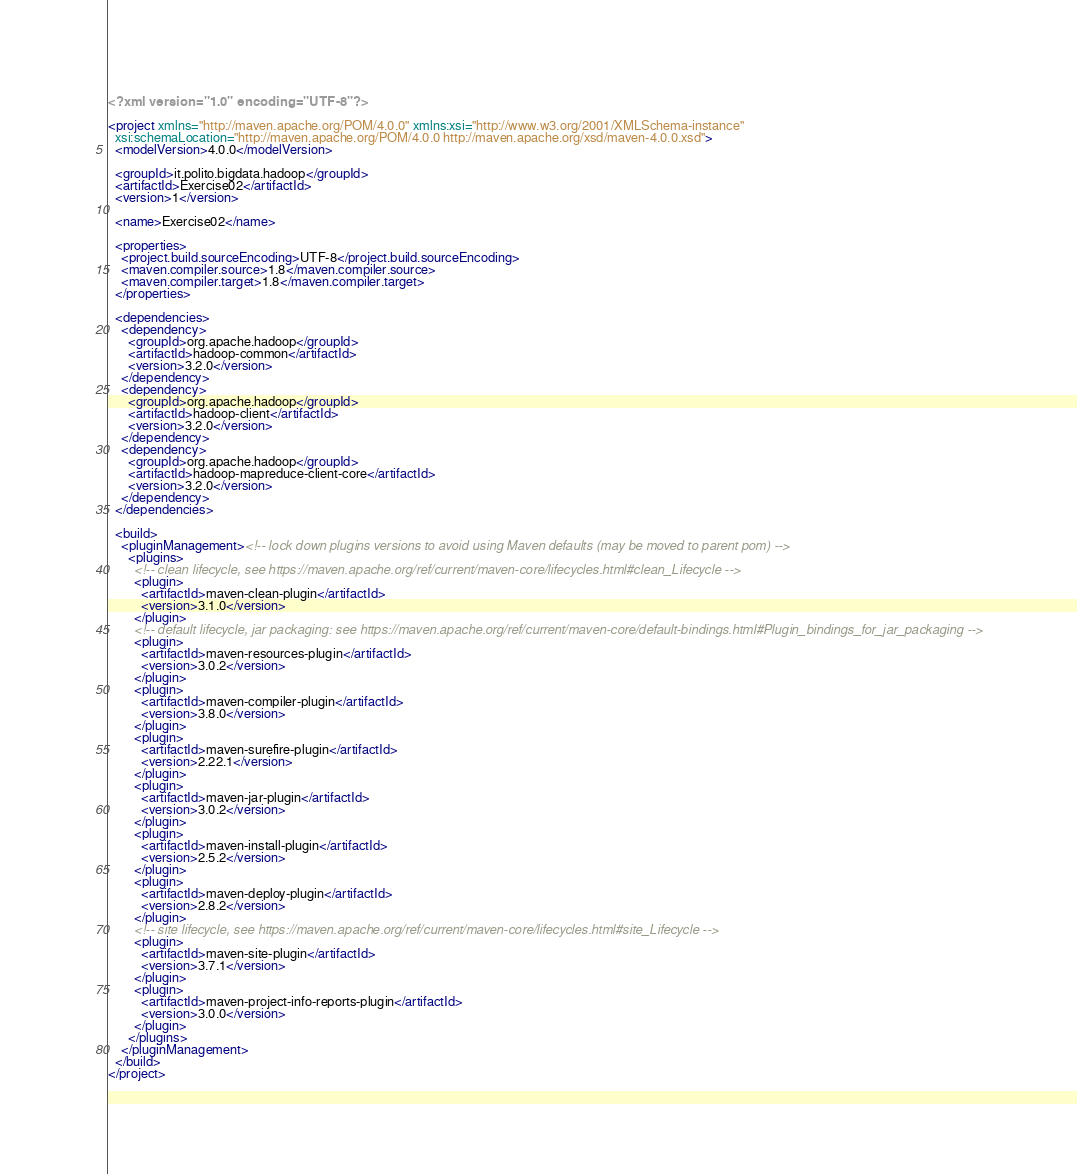<code> <loc_0><loc_0><loc_500><loc_500><_XML_><?xml version="1.0" encoding="UTF-8"?>

<project xmlns="http://maven.apache.org/POM/4.0.0" xmlns:xsi="http://www.w3.org/2001/XMLSchema-instance"
  xsi:schemaLocation="http://maven.apache.org/POM/4.0.0 http://maven.apache.org/xsd/maven-4.0.0.xsd">
  <modelVersion>4.0.0</modelVersion>

  <groupId>it.polito.bigdata.hadoop</groupId>
  <artifactId>Exercise02</artifactId>
  <version>1</version>

  <name>Exercise02</name>

  <properties>
    <project.build.sourceEncoding>UTF-8</project.build.sourceEncoding>
    <maven.compiler.source>1.8</maven.compiler.source>
    <maven.compiler.target>1.8</maven.compiler.target>
  </properties>

  <dependencies>
    <dependency>
      <groupId>org.apache.hadoop</groupId>
      <artifactId>hadoop-common</artifactId>
      <version>3.2.0</version>
    </dependency>
    <dependency>
      <groupId>org.apache.hadoop</groupId>
      <artifactId>hadoop-client</artifactId>
      <version>3.2.0</version>
    </dependency>
    <dependency>
      <groupId>org.apache.hadoop</groupId>
      <artifactId>hadoop-mapreduce-client-core</artifactId>
      <version>3.2.0</version>
    </dependency>
  </dependencies>

  <build>
    <pluginManagement><!-- lock down plugins versions to avoid using Maven defaults (may be moved to parent pom) -->
      <plugins>
        <!-- clean lifecycle, see https://maven.apache.org/ref/current/maven-core/lifecycles.html#clean_Lifecycle -->
        <plugin>
          <artifactId>maven-clean-plugin</artifactId>
          <version>3.1.0</version>
        </plugin>
        <!-- default lifecycle, jar packaging: see https://maven.apache.org/ref/current/maven-core/default-bindings.html#Plugin_bindings_for_jar_packaging -->
        <plugin>
          <artifactId>maven-resources-plugin</artifactId>
          <version>3.0.2</version>
        </plugin>
        <plugin>
          <artifactId>maven-compiler-plugin</artifactId>
          <version>3.8.0</version>
        </plugin>
        <plugin>
          <artifactId>maven-surefire-plugin</artifactId>
          <version>2.22.1</version>
        </plugin>
        <plugin>
          <artifactId>maven-jar-plugin</artifactId>
          <version>3.0.2</version>
        </plugin>
        <plugin>
          <artifactId>maven-install-plugin</artifactId>
          <version>2.5.2</version>
        </plugin>
        <plugin>
          <artifactId>maven-deploy-plugin</artifactId>
          <version>2.8.2</version>
        </plugin>
        <!-- site lifecycle, see https://maven.apache.org/ref/current/maven-core/lifecycles.html#site_Lifecycle -->
        <plugin>
          <artifactId>maven-site-plugin</artifactId>
          <version>3.7.1</version>
        </plugin>
        <plugin>
          <artifactId>maven-project-info-reports-plugin</artifactId>
          <version>3.0.0</version>
        </plugin>
      </plugins>
    </pluginManagement>
  </build>
</project>
</code> 